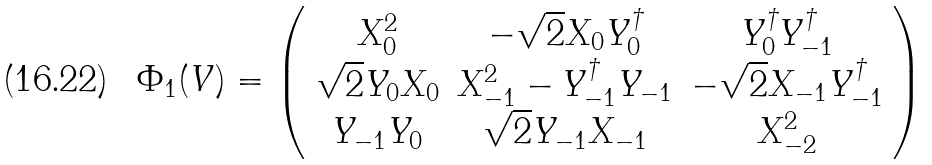Convert formula to latex. <formula><loc_0><loc_0><loc_500><loc_500>\Phi _ { 1 } ( V ) = \left ( \begin{array} { c c c } X _ { 0 } ^ { 2 } & - \sqrt { 2 } X _ { 0 } Y _ { 0 } ^ { \dagger } & Y _ { 0 } ^ { \dagger } Y _ { - 1 } ^ { \dagger } \\ \sqrt { 2 } Y _ { 0 } X _ { 0 } & X _ { - 1 } ^ { 2 } - Y _ { - 1 } ^ { \dagger } Y _ { - 1 } & - \sqrt { 2 } X _ { - 1 } Y _ { - 1 } ^ { \dagger } \\ Y _ { - 1 } Y _ { 0 } & \sqrt { 2 } Y _ { - 1 } X _ { - 1 } & X _ { - 2 } ^ { 2 } \end{array} \right )</formula> 